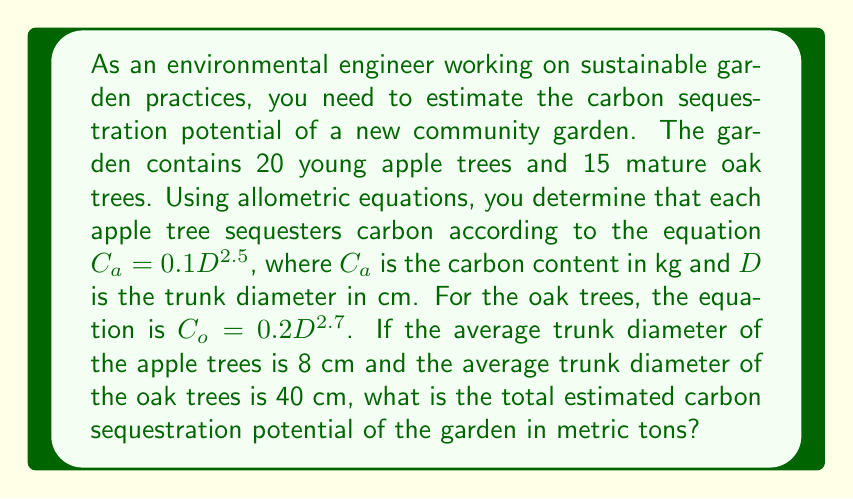Solve this math problem. To solve this problem, we need to follow these steps:

1. Calculate the carbon content for a single apple tree:
   $$C_a = 0.1D^{2.5} = 0.1 \cdot 8^{2.5} = 0.1 \cdot 181.0193 = 18.10193 \text{ kg}$$

2. Calculate the carbon content for all apple trees:
   $$C_{total\_apple} = 20 \cdot 18.10193 = 362.0386 \text{ kg}$$

3. Calculate the carbon content for a single oak tree:
   $$C_o = 0.2D^{2.7} = 0.2 \cdot 40^{2.7} = 0.2 \cdot 27856.8129 = 5571.3626 \text{ kg}$$

4. Calculate the carbon content for all oak trees:
   $$C_{total\_oak} = 15 \cdot 5571.3626 = 83570.439 \text{ kg}$$

5. Sum up the total carbon content:
   $$C_{total} = C_{total\_apple} + C_{total\_oak} = 362.0386 + 83570.439 = 83932.4776 \text{ kg}$$

6. Convert the result from kg to metric tons:
   $$C_{total\_tons} = \frac{83932.4776}{1000} = 83.9325 \text{ metric tons}$$
Answer: 83.9325 metric tons 